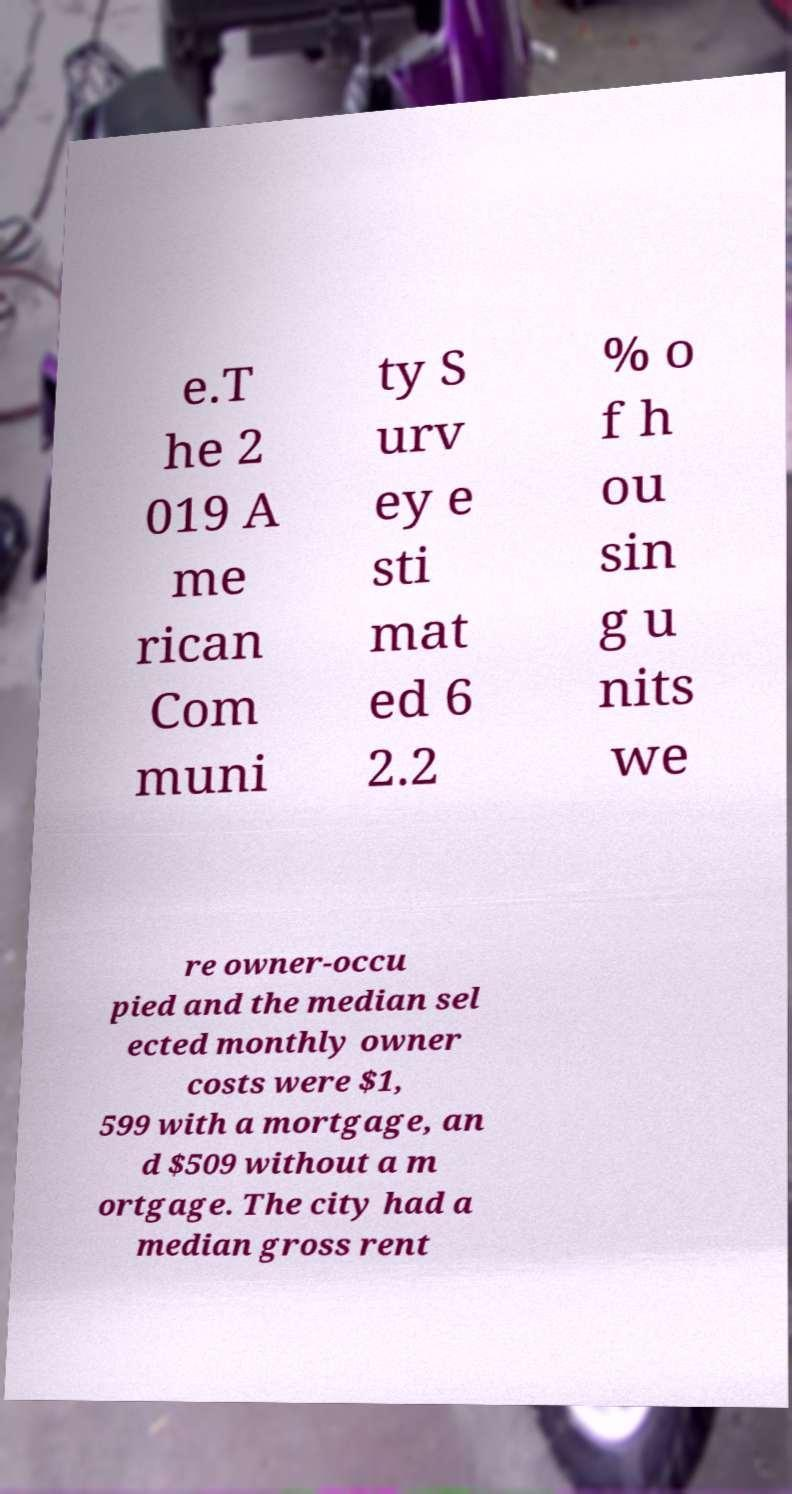There's text embedded in this image that I need extracted. Can you transcribe it verbatim? e.T he 2 019 A me rican Com muni ty S urv ey e sti mat ed 6 2.2 % o f h ou sin g u nits we re owner-occu pied and the median sel ected monthly owner costs were $1, 599 with a mortgage, an d $509 without a m ortgage. The city had a median gross rent 